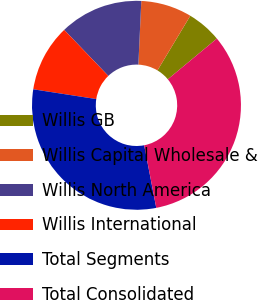Convert chart to OTSL. <chart><loc_0><loc_0><loc_500><loc_500><pie_chart><fcel>Willis GB<fcel>Willis Capital Wholesale &<fcel>Willis North America<fcel>Willis International<fcel>Total Segments<fcel>Total Consolidated<nl><fcel>5.36%<fcel>7.88%<fcel>12.9%<fcel>10.39%<fcel>30.48%<fcel>32.99%<nl></chart> 